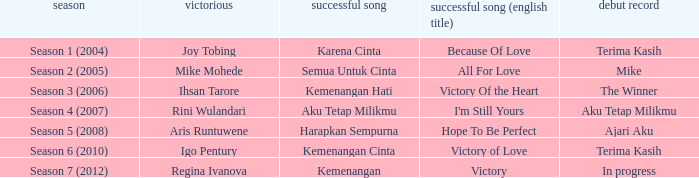Which English winning song had the winner aris runtuwene? Hope To Be Perfect. 